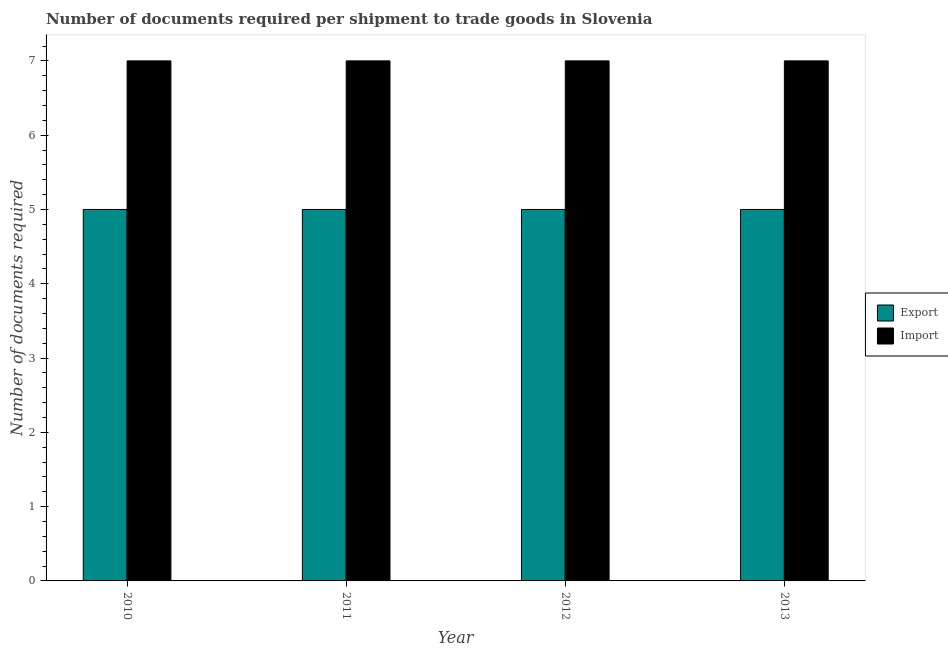How many groups of bars are there?
Your answer should be compact. 4. Are the number of bars per tick equal to the number of legend labels?
Your answer should be compact. Yes. How many bars are there on the 3rd tick from the left?
Ensure brevity in your answer.  2. What is the label of the 2nd group of bars from the left?
Your response must be concise. 2011. In how many cases, is the number of bars for a given year not equal to the number of legend labels?
Your answer should be compact. 0. What is the number of documents required to import goods in 2013?
Offer a very short reply. 7. Across all years, what is the maximum number of documents required to export goods?
Your answer should be compact. 5. Across all years, what is the minimum number of documents required to export goods?
Provide a succinct answer. 5. In which year was the number of documents required to export goods minimum?
Provide a short and direct response. 2010. What is the total number of documents required to export goods in the graph?
Offer a terse response. 20. What is the difference between the number of documents required to import goods in 2013 and the number of documents required to export goods in 2011?
Provide a succinct answer. 0. What is the average number of documents required to import goods per year?
Provide a short and direct response. 7. In the year 2012, what is the difference between the number of documents required to import goods and number of documents required to export goods?
Your answer should be very brief. 0. In how many years, is the number of documents required to export goods greater than 6.4?
Provide a short and direct response. 0. What is the difference between the highest and the lowest number of documents required to import goods?
Offer a terse response. 0. What does the 1st bar from the left in 2011 represents?
Provide a succinct answer. Export. What does the 2nd bar from the right in 2012 represents?
Provide a succinct answer. Export. How many years are there in the graph?
Your response must be concise. 4. What is the difference between two consecutive major ticks on the Y-axis?
Provide a short and direct response. 1. Does the graph contain grids?
Your response must be concise. No. Where does the legend appear in the graph?
Make the answer very short. Center right. What is the title of the graph?
Offer a terse response. Number of documents required per shipment to trade goods in Slovenia. Does "International Tourists" appear as one of the legend labels in the graph?
Make the answer very short. No. What is the label or title of the Y-axis?
Your answer should be very brief. Number of documents required. What is the Number of documents required of Export in 2010?
Provide a short and direct response. 5. What is the Number of documents required of Export in 2011?
Provide a succinct answer. 5. What is the Number of documents required in Import in 2011?
Offer a terse response. 7. What is the Number of documents required of Export in 2012?
Keep it short and to the point. 5. What is the Number of documents required of Import in 2012?
Offer a very short reply. 7. What is the Number of documents required in Export in 2013?
Provide a short and direct response. 5. Across all years, what is the maximum Number of documents required of Import?
Offer a very short reply. 7. Across all years, what is the minimum Number of documents required in Import?
Your answer should be compact. 7. What is the difference between the Number of documents required in Import in 2010 and that in 2011?
Keep it short and to the point. 0. What is the difference between the Number of documents required in Export in 2010 and that in 2012?
Keep it short and to the point. 0. What is the difference between the Number of documents required of Import in 2010 and that in 2012?
Provide a succinct answer. 0. What is the difference between the Number of documents required of Export in 2010 and that in 2013?
Your response must be concise. 0. What is the difference between the Number of documents required in Import in 2010 and that in 2013?
Keep it short and to the point. 0. What is the difference between the Number of documents required in Export in 2011 and that in 2012?
Provide a short and direct response. 0. What is the difference between the Number of documents required in Import in 2011 and that in 2012?
Give a very brief answer. 0. What is the difference between the Number of documents required in Export in 2011 and that in 2013?
Provide a short and direct response. 0. What is the difference between the Number of documents required in Export in 2012 and that in 2013?
Provide a succinct answer. 0. What is the difference between the Number of documents required in Import in 2012 and that in 2013?
Keep it short and to the point. 0. What is the difference between the Number of documents required of Export in 2010 and the Number of documents required of Import in 2011?
Give a very brief answer. -2. What is the difference between the Number of documents required in Export in 2010 and the Number of documents required in Import in 2012?
Keep it short and to the point. -2. What is the difference between the Number of documents required of Export in 2010 and the Number of documents required of Import in 2013?
Ensure brevity in your answer.  -2. What is the difference between the Number of documents required of Export in 2011 and the Number of documents required of Import in 2013?
Make the answer very short. -2. What is the ratio of the Number of documents required of Export in 2010 to that in 2011?
Give a very brief answer. 1. What is the ratio of the Number of documents required in Import in 2010 to that in 2012?
Your response must be concise. 1. What is the ratio of the Number of documents required of Export in 2010 to that in 2013?
Offer a very short reply. 1. What is the ratio of the Number of documents required in Import in 2010 to that in 2013?
Give a very brief answer. 1. What is the ratio of the Number of documents required in Export in 2011 to that in 2013?
Provide a succinct answer. 1. What is the ratio of the Number of documents required in Export in 2012 to that in 2013?
Give a very brief answer. 1. What is the ratio of the Number of documents required of Import in 2012 to that in 2013?
Provide a succinct answer. 1. What is the difference between the highest and the second highest Number of documents required of Export?
Offer a very short reply. 0. What is the difference between the highest and the second highest Number of documents required of Import?
Make the answer very short. 0. What is the difference between the highest and the lowest Number of documents required in Export?
Provide a succinct answer. 0. 